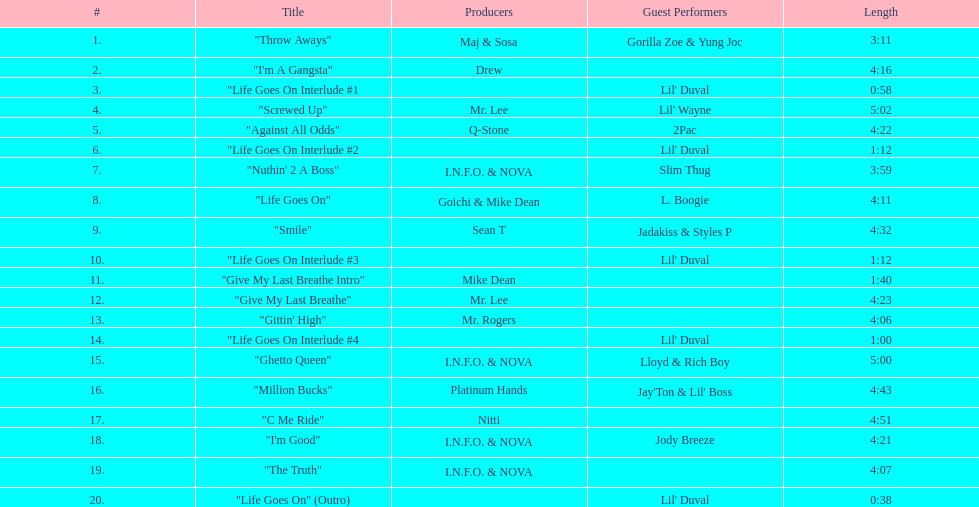Which songs on this album have the same producer(s) in a consecutive sequence? "I'm Good", "The Truth". 